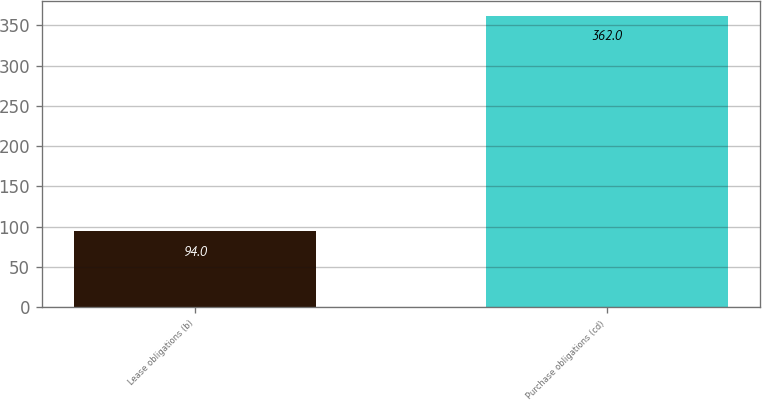<chart> <loc_0><loc_0><loc_500><loc_500><bar_chart><fcel>Lease obligations (b)<fcel>Purchase obligations (cd)<nl><fcel>94<fcel>362<nl></chart> 